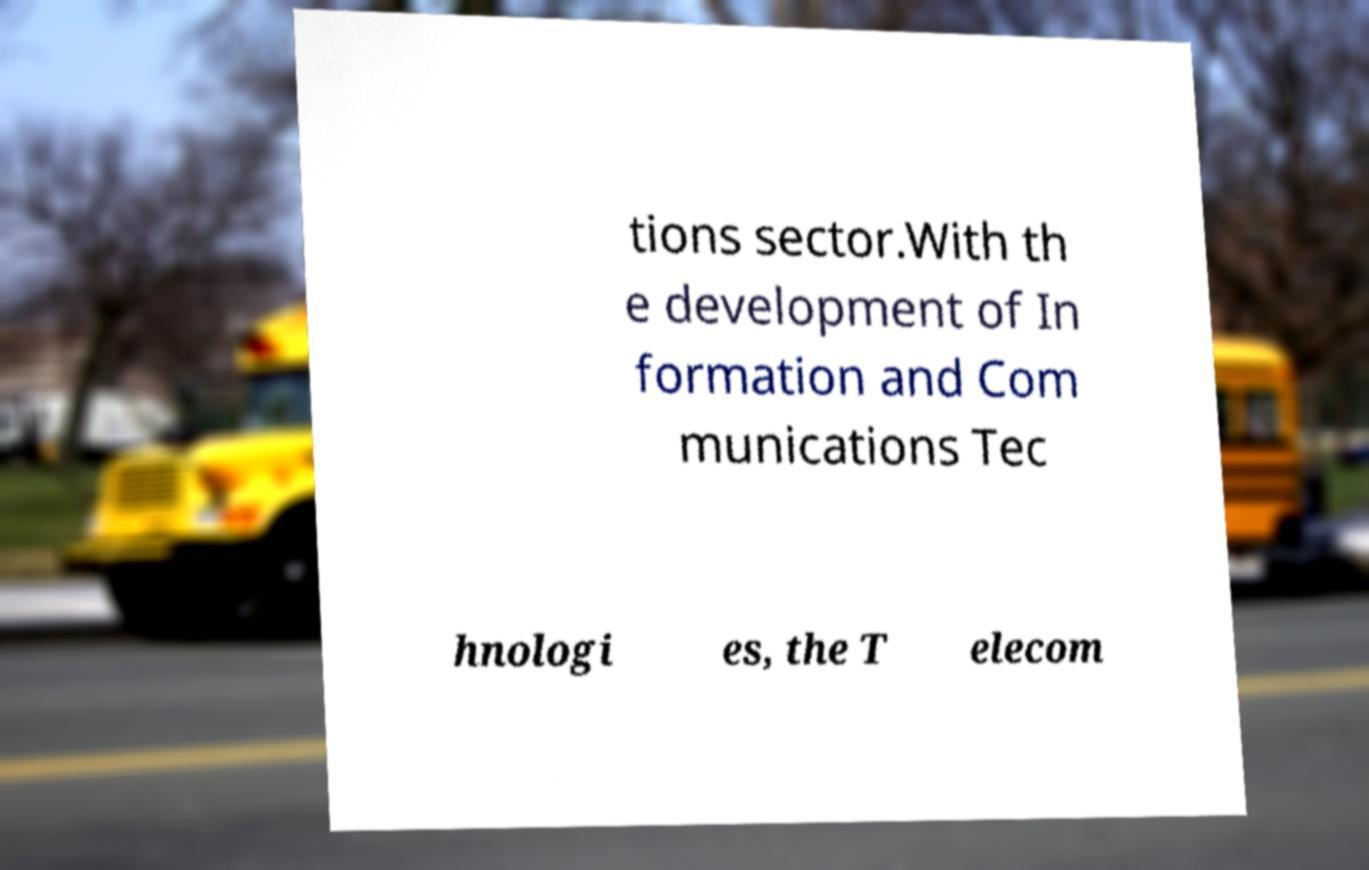There's text embedded in this image that I need extracted. Can you transcribe it verbatim? tions sector.With th e development of In formation and Com munications Tec hnologi es, the T elecom 